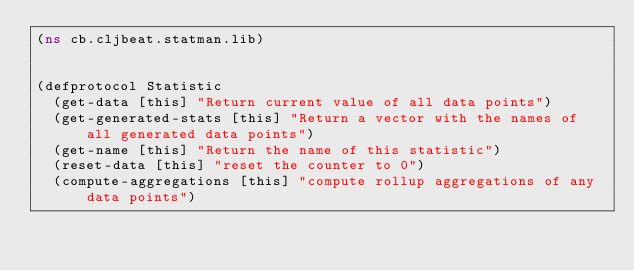<code> <loc_0><loc_0><loc_500><loc_500><_Clojure_>(ns cb.cljbeat.statman.lib)


(defprotocol Statistic
  (get-data [this] "Return current value of all data points")
  (get-generated-stats [this] "Return a vector with the names of all generated data points")
  (get-name [this] "Return the name of this statistic")
  (reset-data [this] "reset the counter to 0")
  (compute-aggregations [this] "compute rollup aggregations of any data points")</code> 